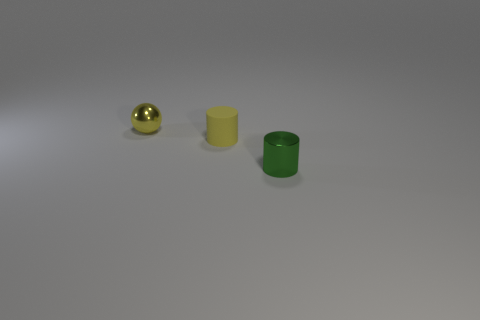Add 2 small rubber objects. How many objects exist? 5 Subtract 0 green spheres. How many objects are left? 3 Subtract all balls. How many objects are left? 2 Subtract all tiny balls. Subtract all spheres. How many objects are left? 1 Add 2 yellow metallic spheres. How many yellow metallic spheres are left? 3 Add 1 large blue matte spheres. How many large blue matte spheres exist? 1 